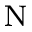<formula> <loc_0><loc_0><loc_500><loc_500>_ { N }</formula> 